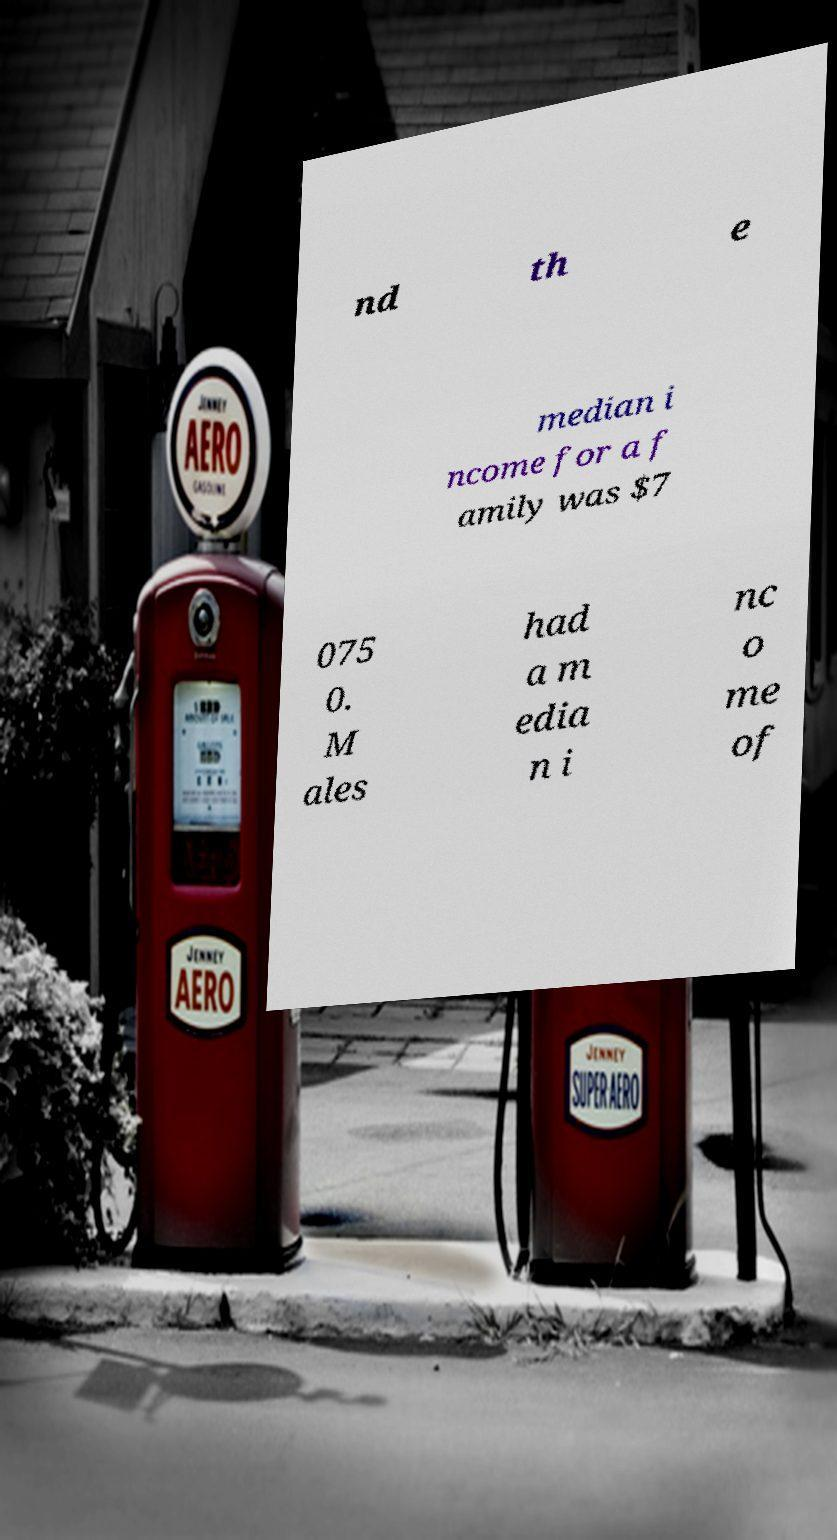What messages or text are displayed in this image? I need them in a readable, typed format. nd th e median i ncome for a f amily was $7 075 0. M ales had a m edia n i nc o me of 